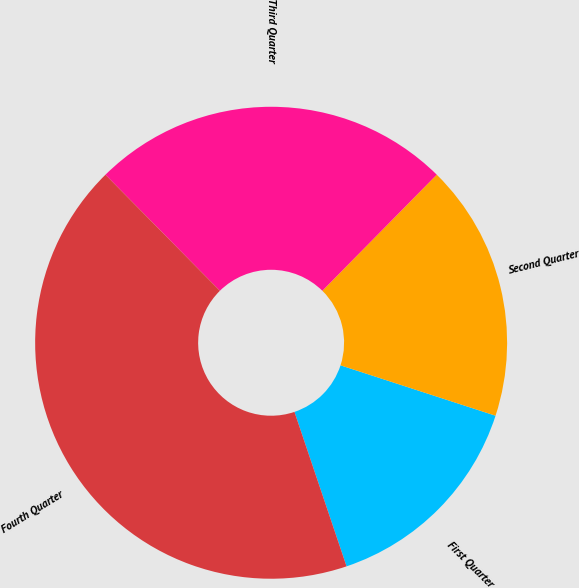Convert chart to OTSL. <chart><loc_0><loc_0><loc_500><loc_500><pie_chart><fcel>First Quarter<fcel>Second Quarter<fcel>Third Quarter<fcel>Fourth Quarter<nl><fcel>14.82%<fcel>17.62%<fcel>24.77%<fcel>42.79%<nl></chart> 